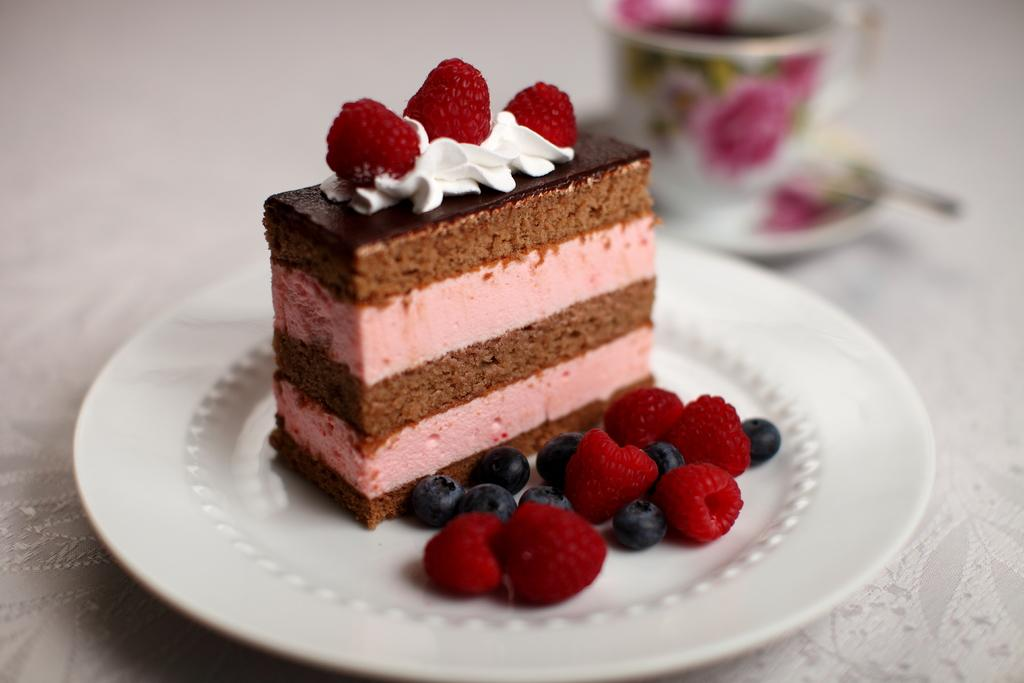What type of pastry is featured in the image? There is a chocolate pastry with strawberries in the image. What is the pastry placed on? The pastry is on a white plate. Where is the plate located? The plate is placed on a table top. What other item can be seen on the table top? There is a pink color tea cup in the image. What type of insurance policy is being discussed in the image? There is no mention of insurance in the image; it features a chocolate pastry with strawberries, a white plate, a table top, and a pink color tea cup. 